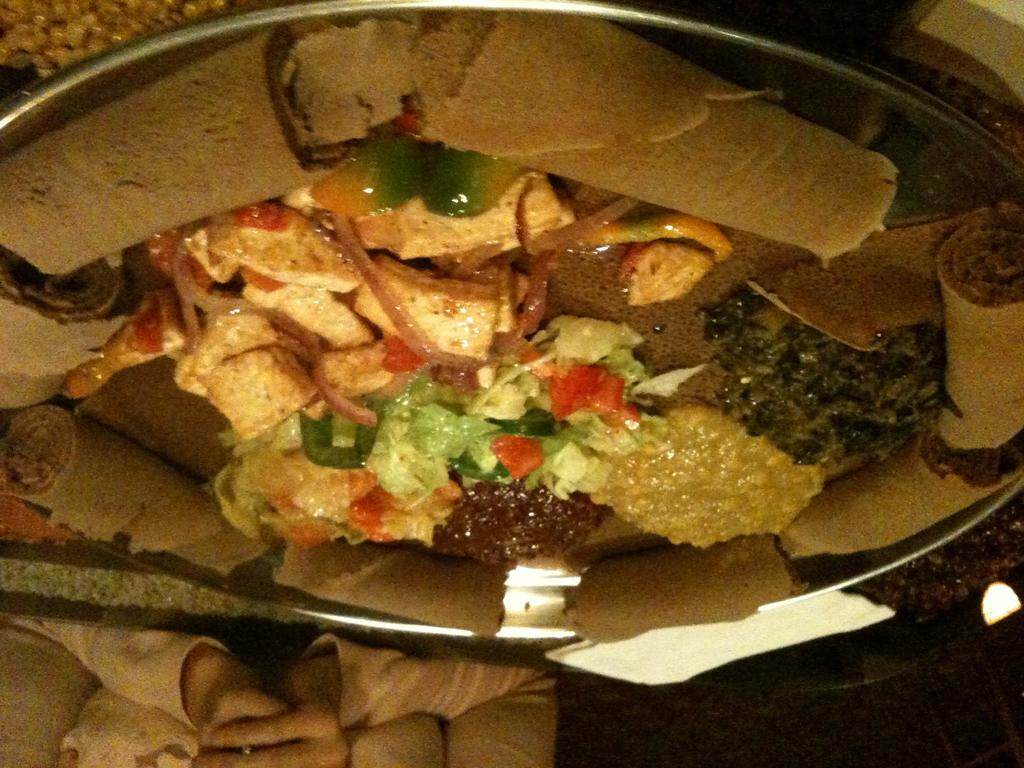What is present on the plate in the image? There are food items in a plate in the image. Can you describe any other elements in the image? The hands of a person are visible in the image. What level of security clearance does the person with the visible hands have in the image? There is no information about security clearance or any indication of a spy-related context in the image. 